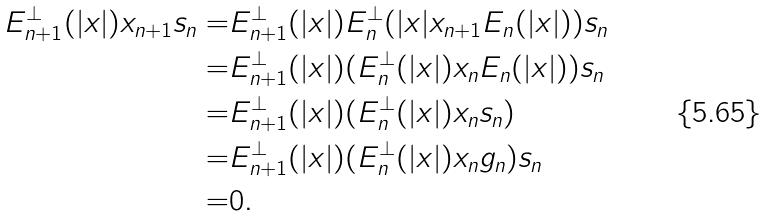<formula> <loc_0><loc_0><loc_500><loc_500>E _ { n + 1 } ^ { \bot } ( | x | ) x _ { n + 1 } s _ { n } = & E _ { n + 1 } ^ { \bot } ( | x | ) E _ { n } ^ { \bot } ( | x | x _ { n + 1 } E _ { n } ( | x | ) ) s _ { n } \\ = & E _ { n + 1 } ^ { \bot } ( | x | ) ( E _ { n } ^ { \bot } ( | x | ) x _ { n } E _ { n } ( | x | ) ) s _ { n } \\ = & E _ { n + 1 } ^ { \bot } ( | x | ) ( E _ { n } ^ { \bot } ( | x | ) x _ { n } s _ { n } ) \\ = & E _ { n + 1 } ^ { \bot } ( | x | ) ( E _ { n } ^ { \bot } ( | x | ) x _ { n } g _ { n } ) s _ { n } \\ = & 0 .</formula> 